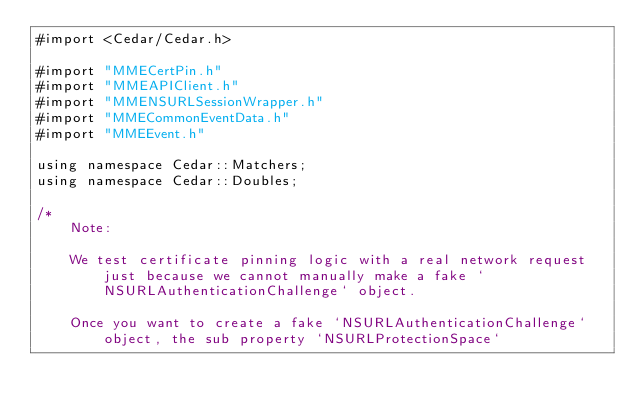Convert code to text. <code><loc_0><loc_0><loc_500><loc_500><_ObjectiveC_>#import <Cedar/Cedar.h>

#import "MMECertPin.h"
#import "MMEAPIClient.h"
#import "MMENSURLSessionWrapper.h"
#import "MMECommonEventData.h"
#import "MMEEvent.h"

using namespace Cedar::Matchers;
using namespace Cedar::Doubles;

/*
    Note:
 
    We test certificate pinning logic with a real network request just because we cannot manually make a fake `NSURLAuthenticationChallenge` object.
 
    Once you want to create a fake `NSURLAuthenticationChallenge` object, the sub property `NSURLProtectionSpace`</code> 